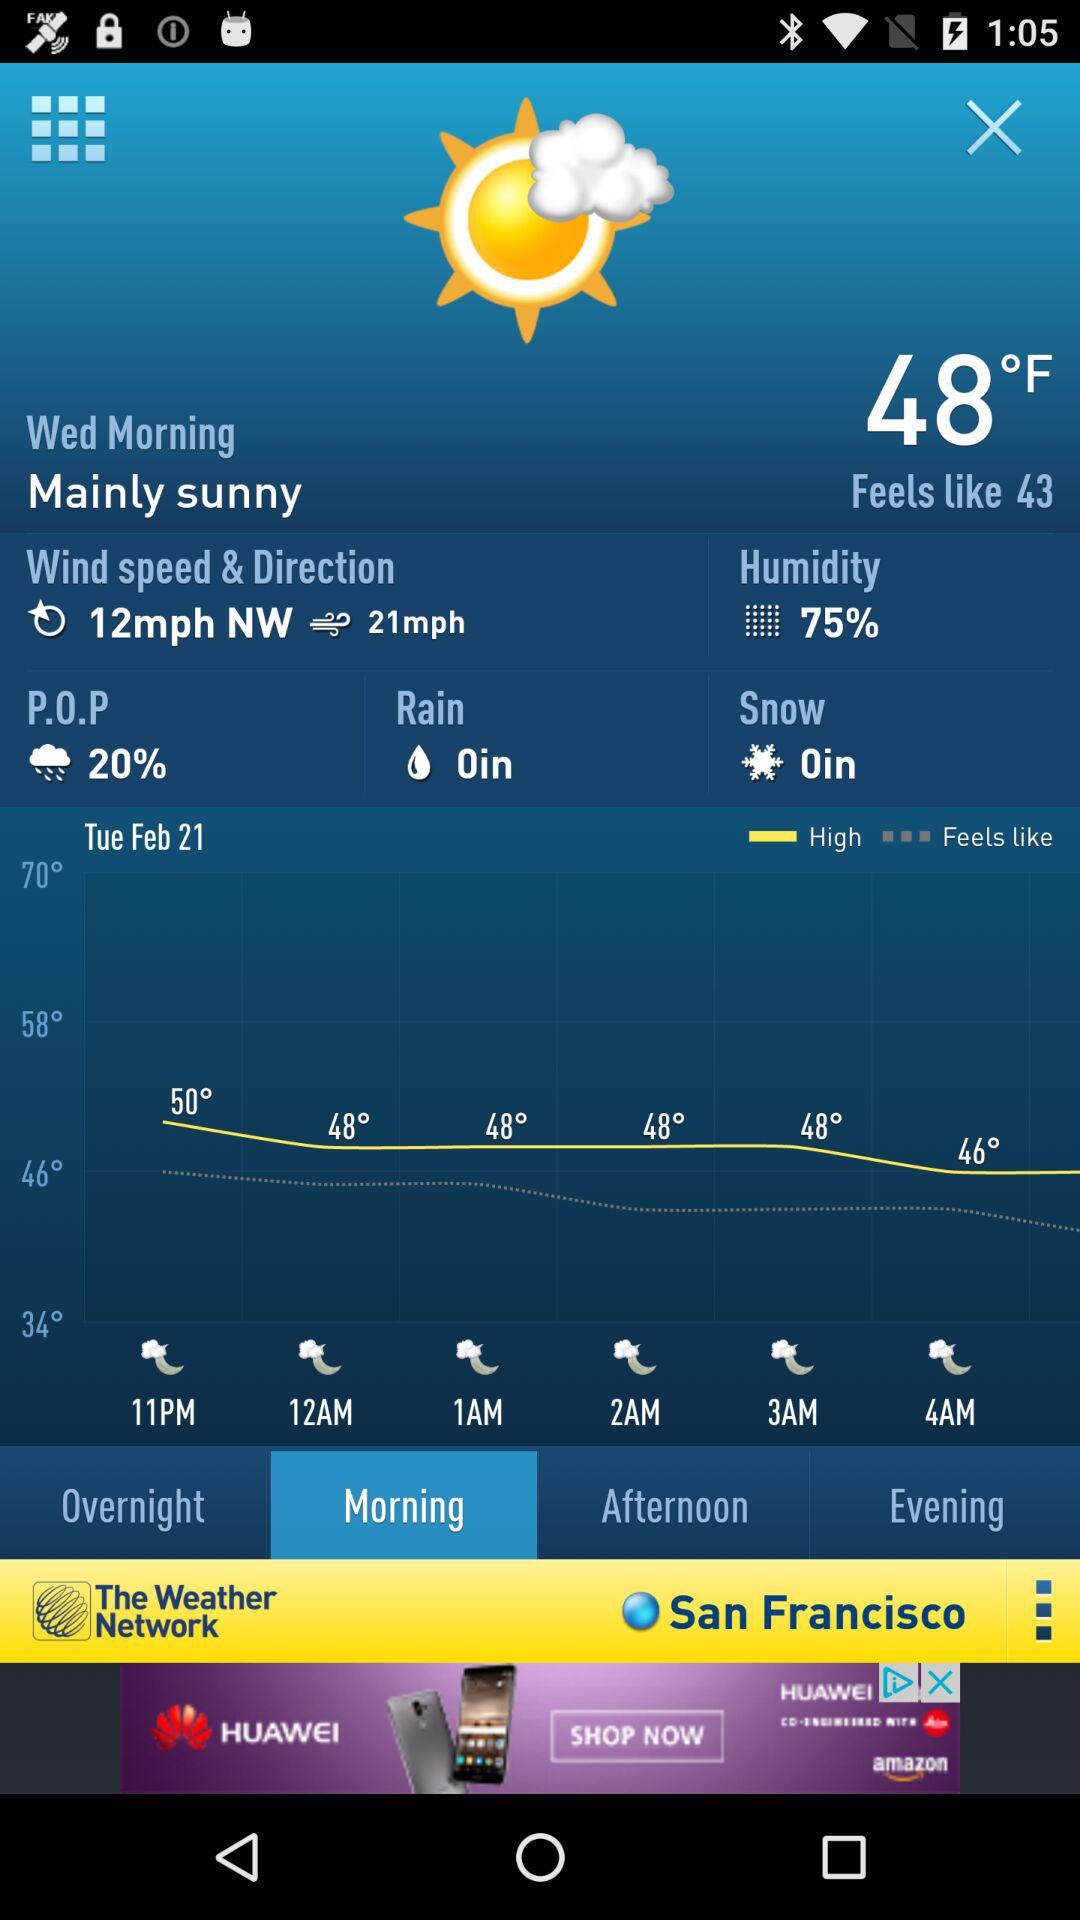What is the unit of temperature? The unit of temperature is °F. 